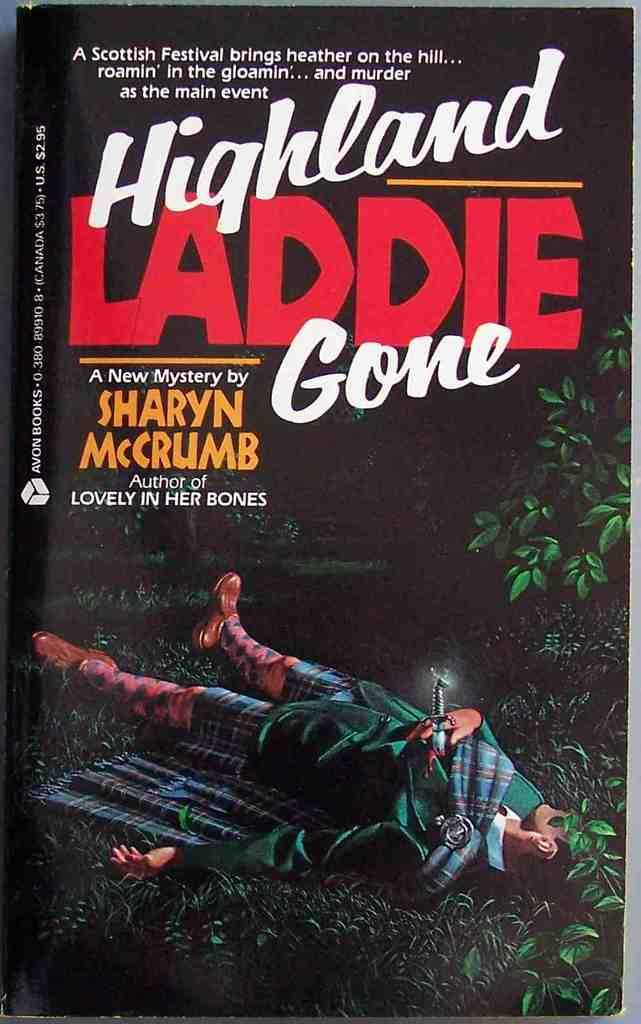<image>
Relay a brief, clear account of the picture shown. A book which is called Highland Laddie Gone. 